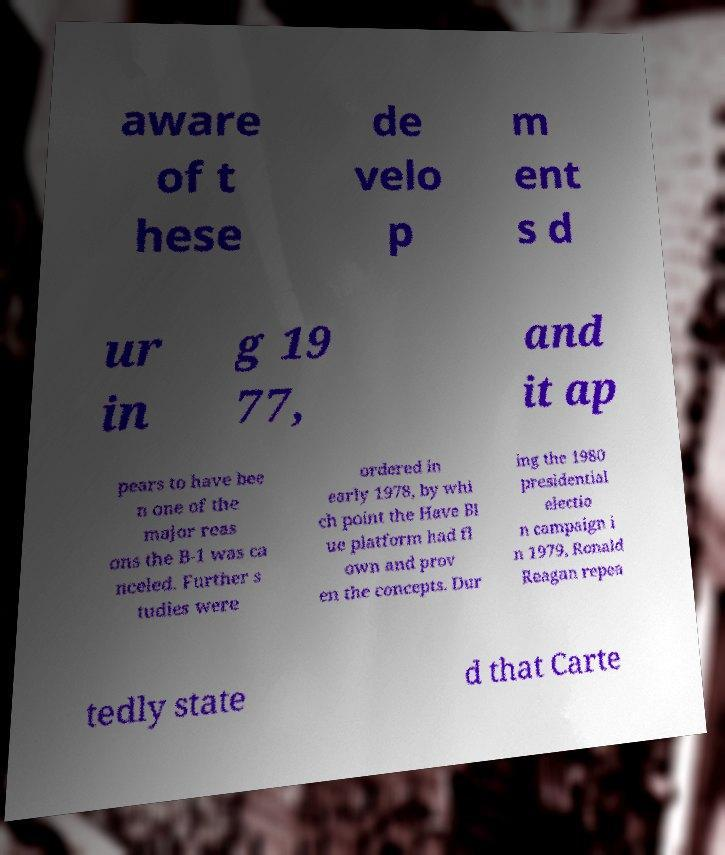For documentation purposes, I need the text within this image transcribed. Could you provide that? aware of t hese de velo p m ent s d ur in g 19 77, and it ap pears to have bee n one of the major reas ons the B-1 was ca nceled. Further s tudies were ordered in early 1978, by whi ch point the Have Bl ue platform had fl own and prov en the concepts. Dur ing the 1980 presidential electio n campaign i n 1979, Ronald Reagan repea tedly state d that Carte 